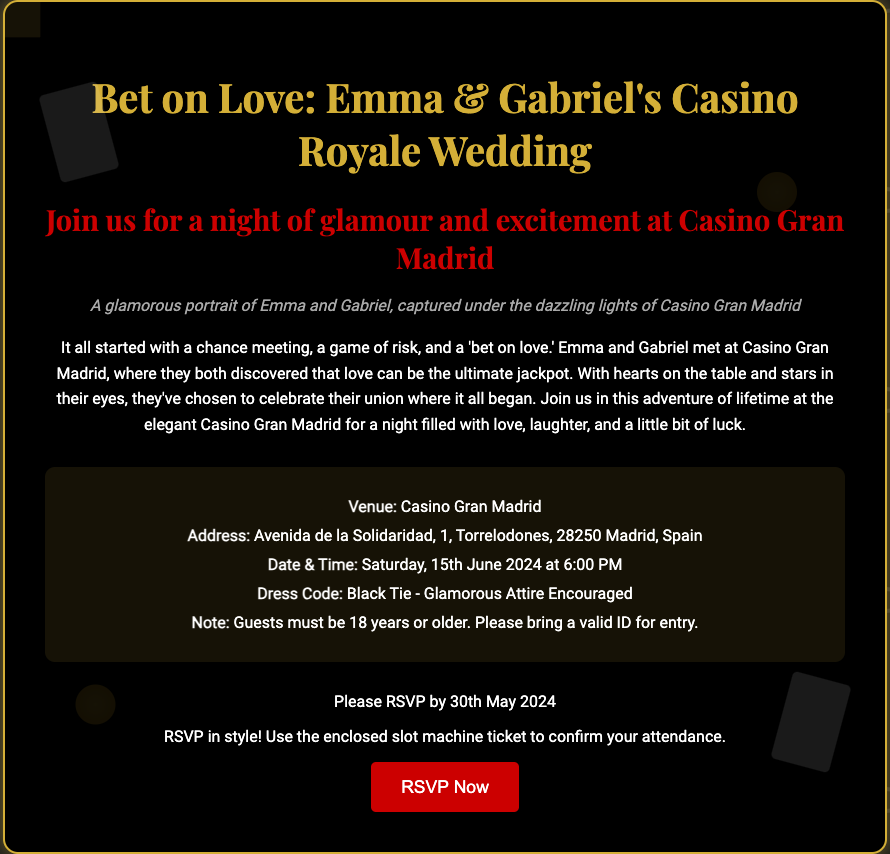What is the name of the couple getting married? The document states the couple's names as Emma and Gabriel.
Answer: Emma & Gabriel Where is the wedding venue located? The invitation provides the venue address as Avenida de la Solidaridad, 1, Torrelodones, 28250 Madrid, Spain.
Answer: Casino Gran Madrid What is the date of the wedding? The event details mention the date of the wedding as Saturday, 15th June 2024.
Answer: 15th June 2024 What is the dress code for the wedding? The dress code specified in the document is "Black Tie - Glamorous Attire Encouraged."
Answer: Black Tie What is the RSVP deadline? The document indicates that the RSVP should be completed by 30th May 2024.
Answer: 30th May 2024 Why did Emma and Gabriel choose this venue? The narrative explains that Emma and Gabriel met at Casino Gran Madrid and want to celebrate their union there.
Answer: They met there What is the main theme of the wedding invitation? The invitation features Casino Royale themes with motifs like playing cards and poker chips.
Answer: Casino Royale What type of RSVP cards are included? The invite includes RSVP cards designed in the form of slot machine tickets.
Answer: Slot machine tickets What is the significance of the phrase "bet on love"? This phrase highlights the couple's adventurous approach to love and their relationship, linking it to the casino theme.
Answer: Their adventurous approach to love 